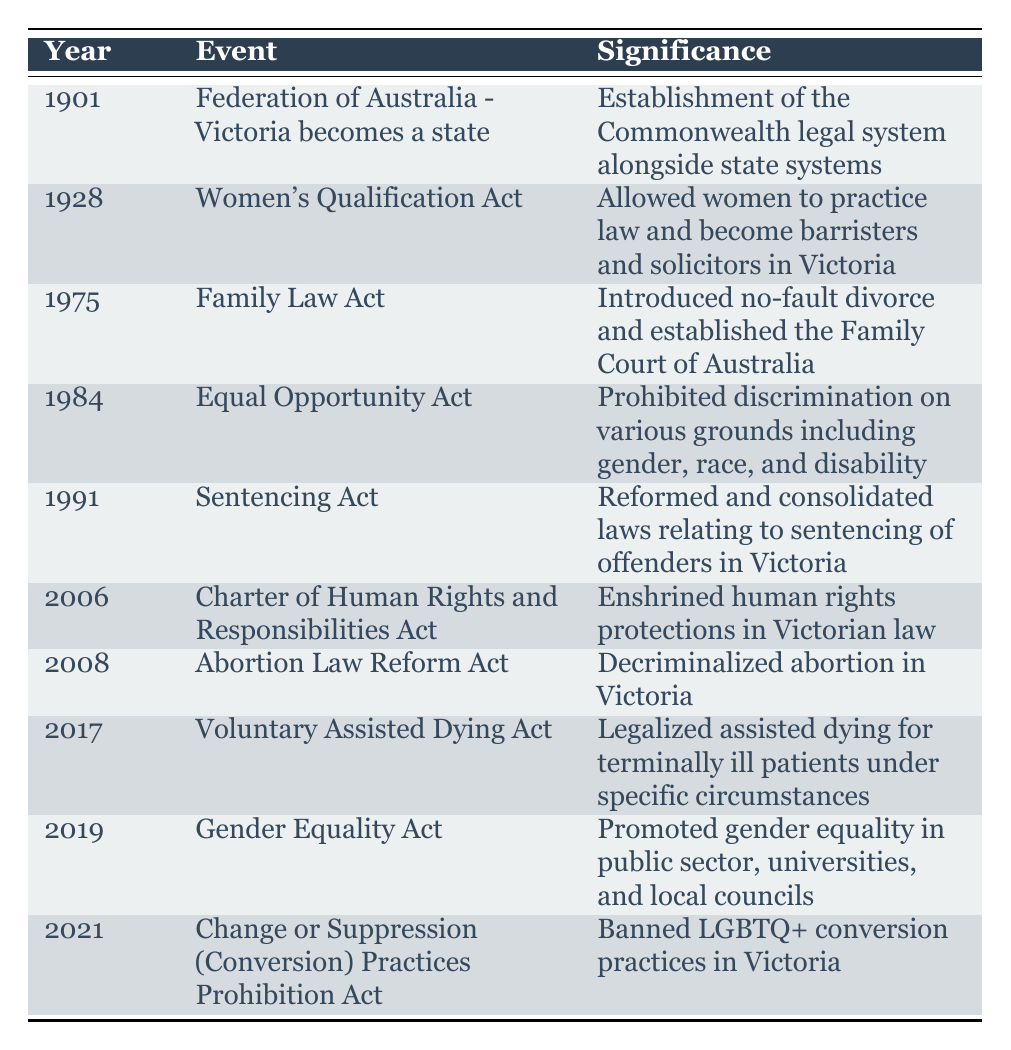What significant legal reform occurred in Victoria in 1928? The table lists the event for 1928 as the Women's Qualification Act, which allowed women to practice law and become barristers and solicitors in Victoria.
Answer: Women's Qualification Act What year was the Charter of Human Rights and Responsibilities Act enacted? According to the table, the Charter of Human Rights and Responsibilities Act was enacted in 2006.
Answer: 2006 How many significant legal reforms were introduced between 2001 and 2021? The events from the table within that range are the Charter of Human Rights and Responsibilities Act (2006), Abortion Law Reform Act (2008), Voluntary Assisted Dying Act (2017), Gender Equality Act (2019), and Change or Suppression (Conversion) Practices Prohibition Act (2021). Counting these, the total is 5 reforms.
Answer: 5 Was the Equal Opportunity Act introduced before or after the Family Law Act? The table clearly shows that the Family Law Act was introduced in 1975 and the Equal Opportunity Act was introduced in 1984. Therefore, the Equal Opportunity Act was introduced after the Family Law Act.
Answer: After Which act reformed laws related to sentencing offenders in Victoria? The table indicates that the Sentencing Act, enacted in 1991, reformed and consolidated laws relating to the sentencing of offenders in Victoria.
Answer: Sentencing Act What is the significance of the 2017 legal reform in Victoria? The table specifies that the 2017 Voluntary Assisted Dying Act legalized assisted dying for terminally ill patients under specific circumstances, which is a significant change in practice for end-of-life care.
Answer: Legalized assisted dying How many acts mentioned in the table address gender equality? There are two acts addressing gender equality: the Equal Opportunity Act (1984) and the Gender Equality Act (2019). When counted together, the total is 2 acts related to gender equality.
Answer: 2 Was the abortion law in Victoria decriminalized before or after 2006? The table states that the Abortion Law Reform Act was enacted in 2008, which is after 2006. Thus, abortion in Victoria was decriminalized after 2006.
Answer: After What legal changes were made regarding LGBTQ+ practices, and in which year did this occur? The Change or Suppression (Conversion) Practices Prohibition Act was enacted in 2021, which banned LGBTQ+ conversion practices in Victoria, representing a significant change for LGBTQ+ rights.
Answer: 2021 